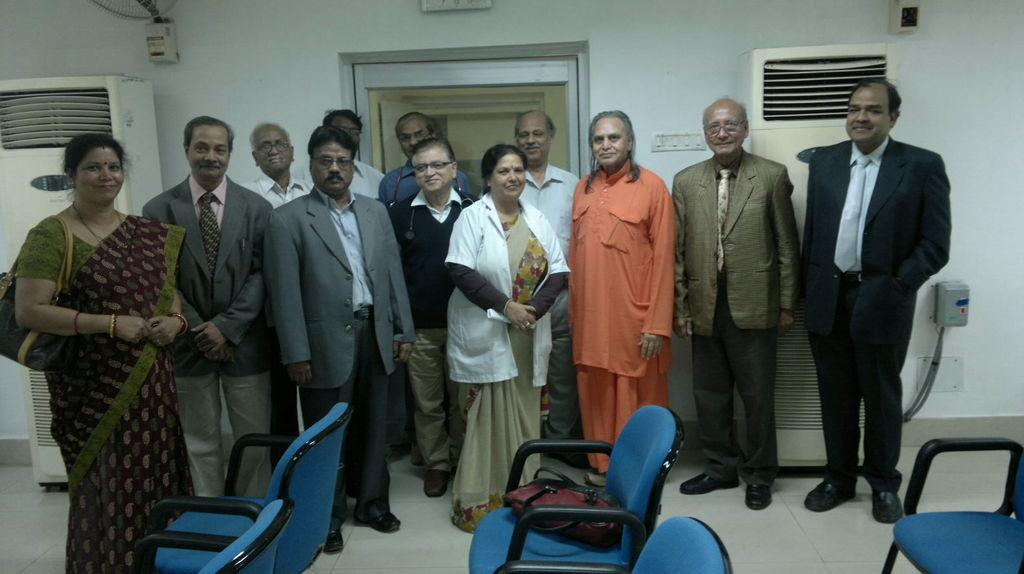How many people are in the image? There are people in the image, but the exact number cannot be determined from the provided facts. What type of furniture is present in the image? There are chairs in the image. What is placed on one of the chairs? There is a bag on a chair. How many air conditioners can be seen in the image? There are two air conditioners in the image. What device is used for controlling electrical appliances in the image? There is a switchboard in the image. What type of architectural elements are visible in the image? There is a wall and a door in the image. What type of pear is being used as a doorstop in the image? There is no pear present in the image, let alone being used as a doorstop. 